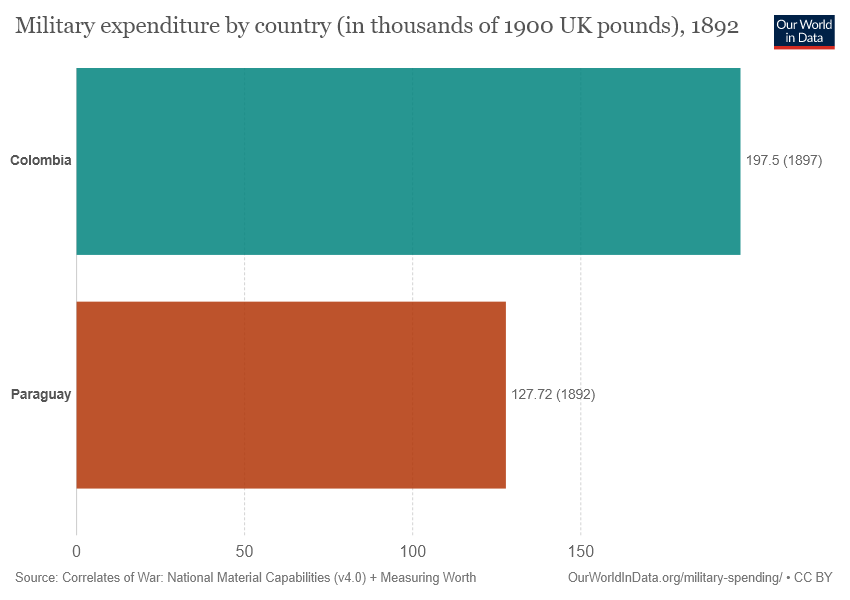Highlight a few significant elements in this photo. The graph uses two bars. What is the difference between both bars? 69.78... 